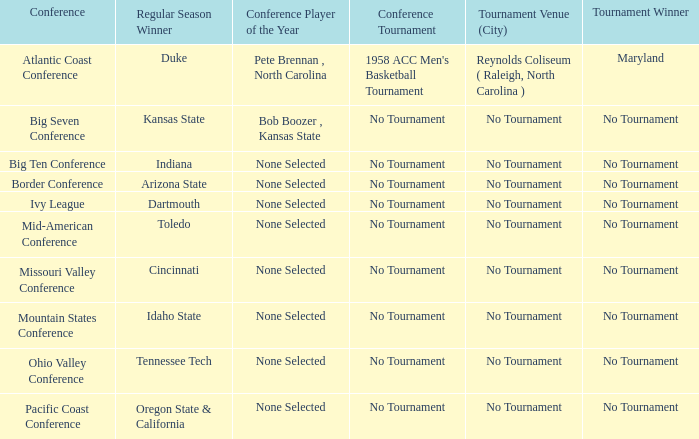Who is the champion of the atlantic coast conference tournament? Maryland. 